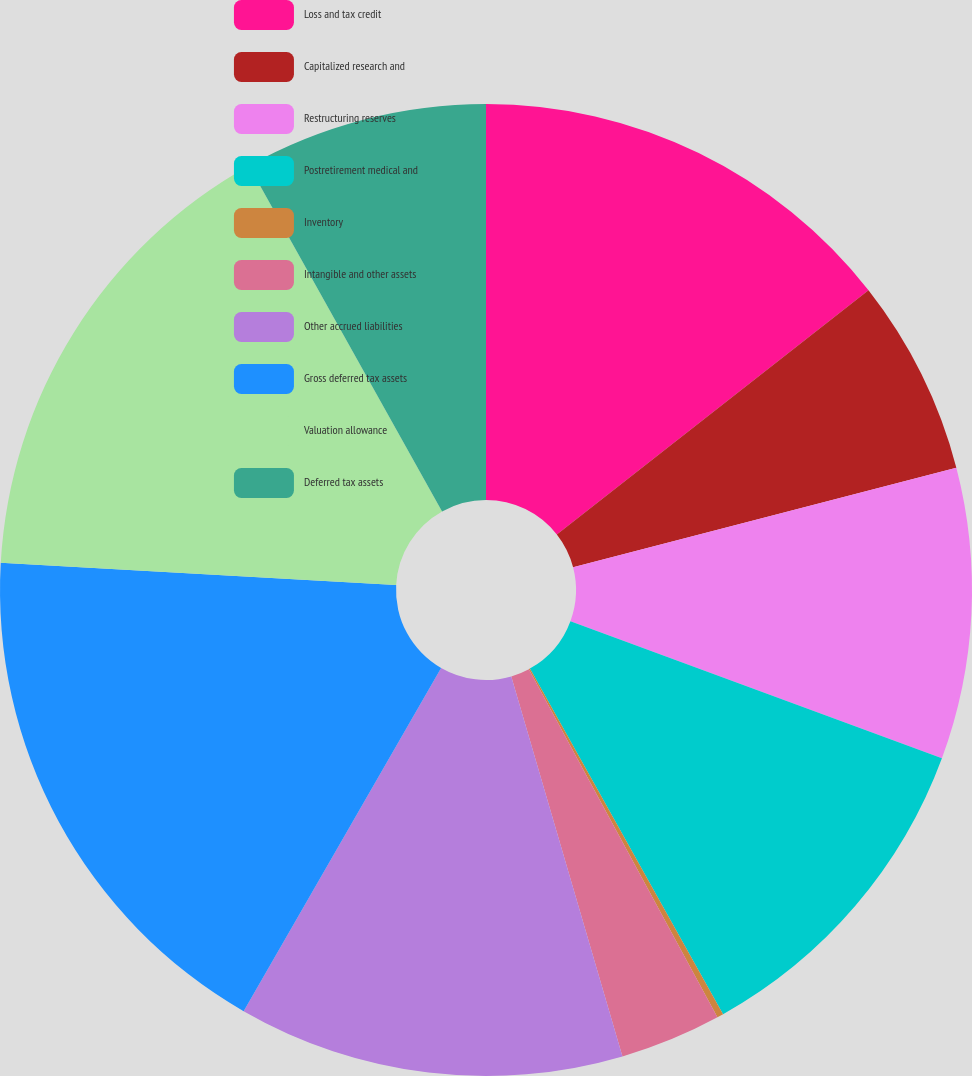<chart> <loc_0><loc_0><loc_500><loc_500><pie_chart><fcel>Loss and tax credit<fcel>Capitalized research and<fcel>Restructuring reserves<fcel>Postretirement medical and<fcel>Inventory<fcel>Intangible and other assets<fcel>Other accrued liabilities<fcel>Gross deferred tax assets<fcel>Valuation allowance<fcel>Deferred tax assets<nl><fcel>14.42%<fcel>6.53%<fcel>9.68%<fcel>11.26%<fcel>0.21%<fcel>3.37%<fcel>12.84%<fcel>17.58%<fcel>16.0%<fcel>8.11%<nl></chart> 